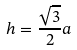<formula> <loc_0><loc_0><loc_500><loc_500>h = \frac { \sqrt { 3 } } { 2 } a</formula> 